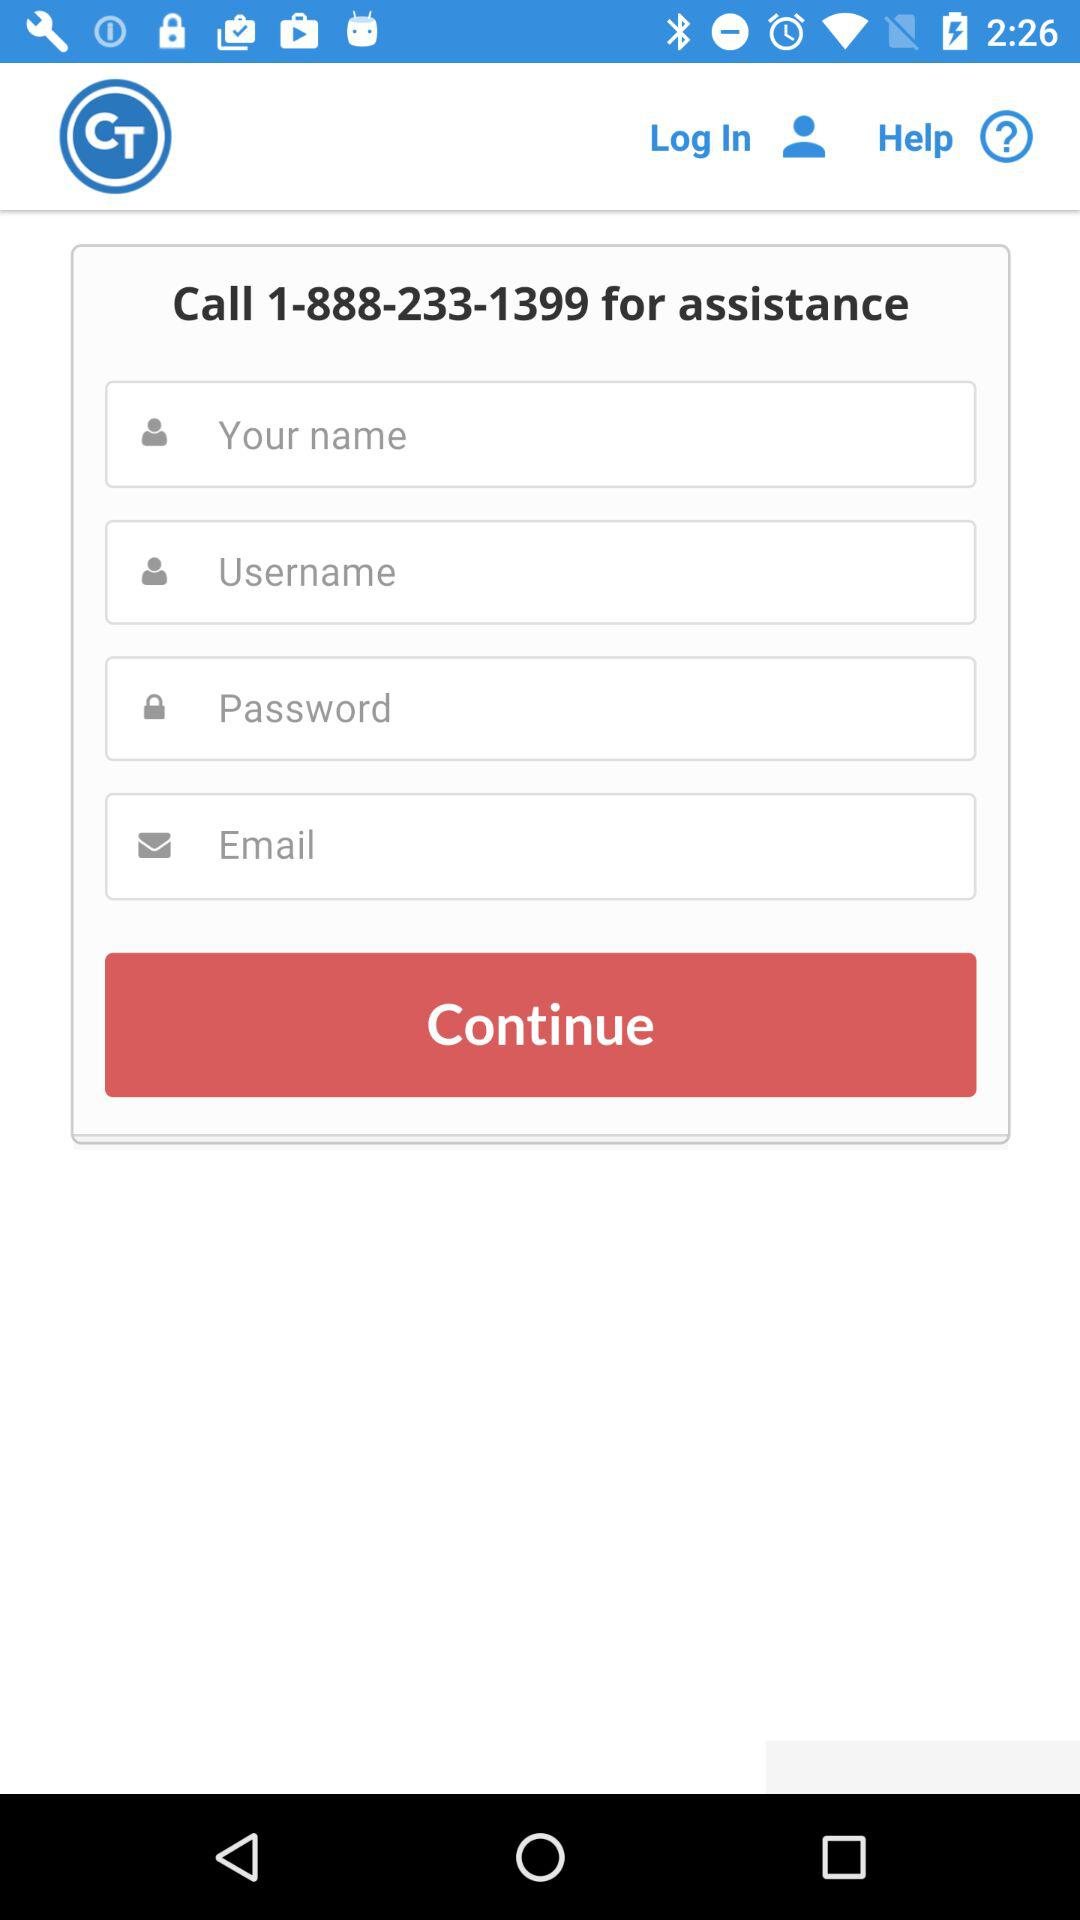How many text inputs are in the form?
Answer the question using a single word or phrase. 4 